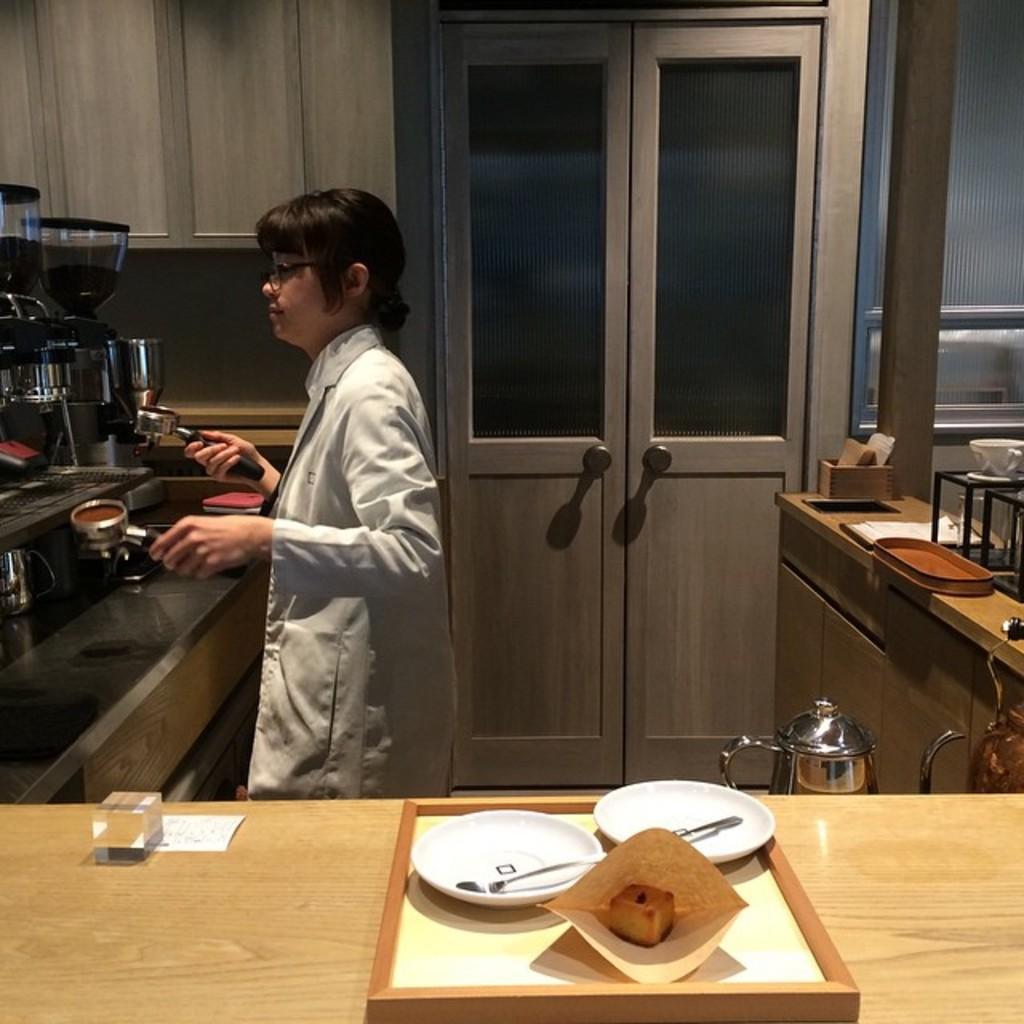Could you give a brief overview of what you see in this image? This picture is clicked inside the room. In front of the picture, we see a table on which plate, spoon and food is placed are placed. There is a woman in white apron is holding a cup of tea. Behind her, we see a table on which papers, box, cup and saucer are placed. Beside that, we see a door. In front of her, we see a coffee machine. 